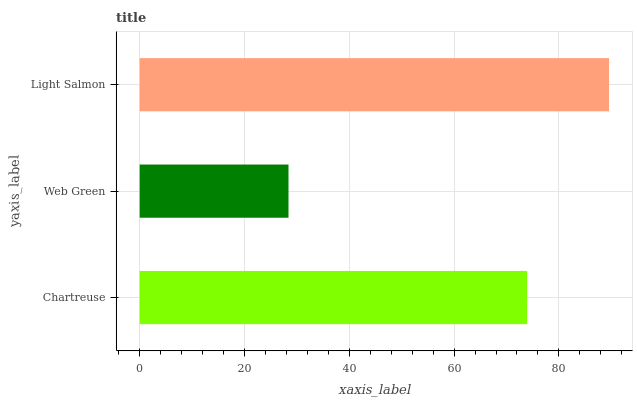Is Web Green the minimum?
Answer yes or no. Yes. Is Light Salmon the maximum?
Answer yes or no. Yes. Is Light Salmon the minimum?
Answer yes or no. No. Is Web Green the maximum?
Answer yes or no. No. Is Light Salmon greater than Web Green?
Answer yes or no. Yes. Is Web Green less than Light Salmon?
Answer yes or no. Yes. Is Web Green greater than Light Salmon?
Answer yes or no. No. Is Light Salmon less than Web Green?
Answer yes or no. No. Is Chartreuse the high median?
Answer yes or no. Yes. Is Chartreuse the low median?
Answer yes or no. Yes. Is Light Salmon the high median?
Answer yes or no. No. Is Light Salmon the low median?
Answer yes or no. No. 